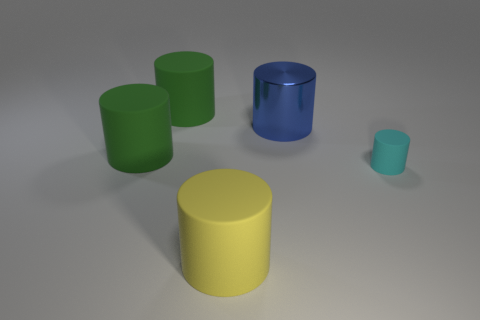Is there any other thing that is the same size as the cyan matte thing?
Ensure brevity in your answer.  No. The large blue shiny thing is what shape?
Your response must be concise. Cylinder. What is the color of the big object that is both behind the small matte cylinder and in front of the big blue metallic thing?
Give a very brief answer. Green. What material is the large yellow object?
Make the answer very short. Rubber. There is a large thing that is to the right of the large yellow thing; what is its shape?
Your answer should be very brief. Cylinder. What color is the other shiny cylinder that is the same size as the yellow cylinder?
Provide a short and direct response. Blue. Do the large thing that is behind the large blue object and the big yellow cylinder have the same material?
Provide a short and direct response. Yes. What size is the rubber cylinder that is behind the tiny matte thing and in front of the large blue thing?
Your response must be concise. Large. How big is the cylinder behind the blue thing?
Ensure brevity in your answer.  Large. What is the shape of the matte thing left of the green matte cylinder that is to the right of the green cylinder in front of the large blue metallic cylinder?
Offer a terse response. Cylinder. 